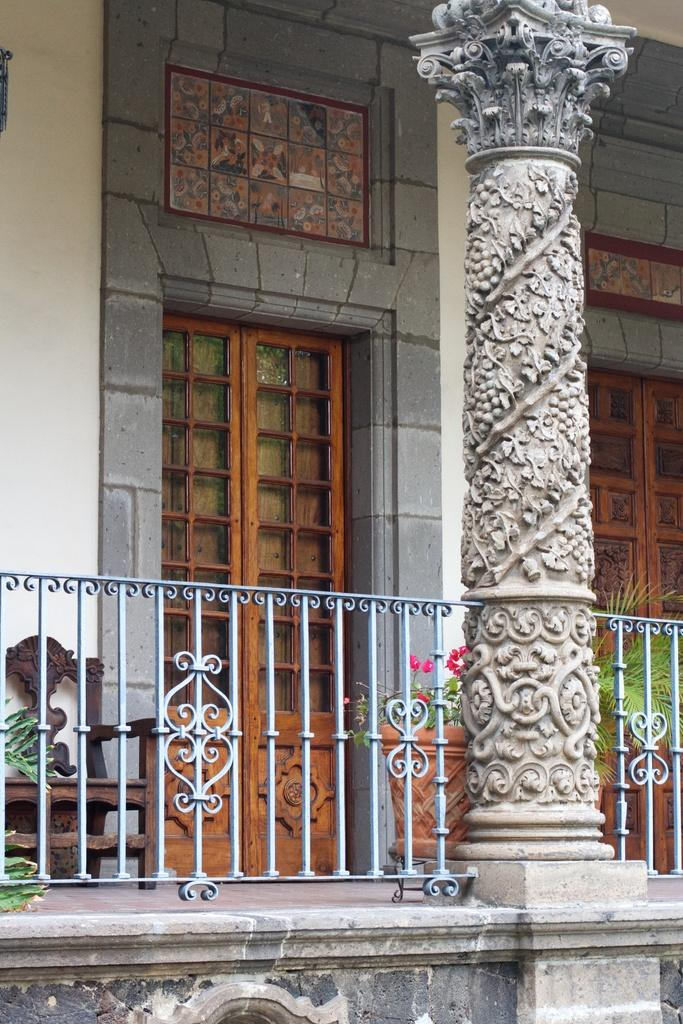What type of structure can be seen in the image? There is a pillar in the image. What objects are present near the pillar? There are flower pots and a wooden chair in the image. What can be seen in the background of the image? There is a stone wall and wooden doors in the background of the image. What month is it in the image? The month cannot be determined from the image, as it does not contain any information about the time of year. How many horses are present in the image? There are no horses present in the image. 